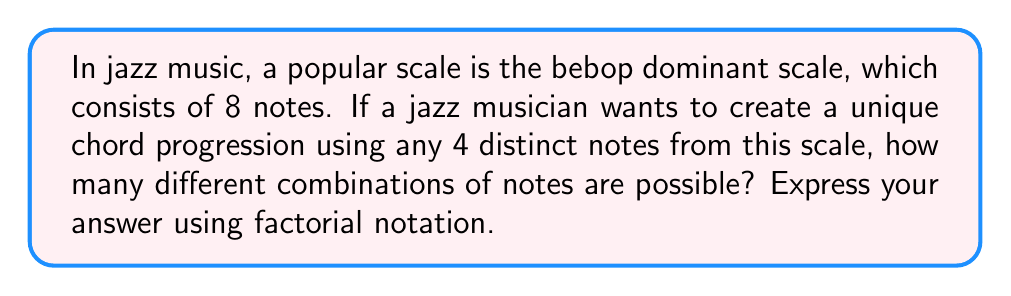Can you answer this question? To solve this problem, we need to use the concept of combinations from combinatorics. 

1) We are selecting 4 distinct notes from a set of 8 notes.

2) The order of selection doesn't matter (e.g., C-E-G-B is the same chord as E-G-B-C).

3) This scenario is perfectly suited for the combination formula:

   $$C(n,r) = \frac{n!}{r!(n-r)!}$$

   where $n$ is the total number of items to choose from, and $r$ is the number of items being chosen.

4) In this case, $n = 8$ (total notes in the bebop dominant scale) and $r = 4$ (notes we're selecting for our chord).

5) Plugging these values into our formula:

   $$C(8,4) = \frac{8!}{4!(8-4)!} = \frac{8!}{4!4!}$$

6) This can be simplified to:

   $$\frac{8 \cdot 7 \cdot 6 \cdot 5 \cdot 4!}{4! \cdot 4 \cdot 3 \cdot 2 \cdot 1}$$

7) The $4!$ cancels out in the numerator and denominator:

   $$\frac{8 \cdot 7 \cdot 6 \cdot 5}{4 \cdot 3 \cdot 2 \cdot 1} = 70$$

Thus, there are 70 possible combinations of 4 notes that can be selected from the 8-note bebop dominant scale.
Answer: $\frac{8!}{4!4!} = 70$ 